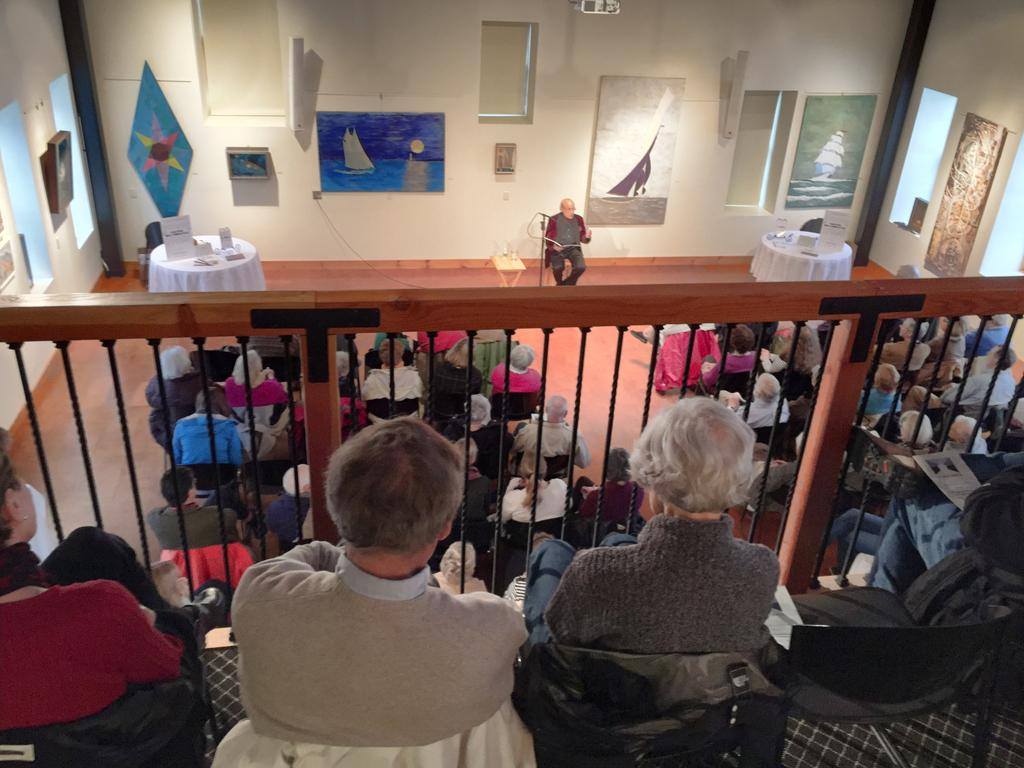What are the people in the image doing? The people in the image are sitting on chairs. What can be seen in the background of the image? There is a railing, other people sitting, a wall, and a board visible in the background. What type of land can be seen in the image? There is no specific type of land visible in the image; it is an indoor setting with chairs, a railing, and other background elements. 